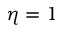<formula> <loc_0><loc_0><loc_500><loc_500>\eta = 1</formula> 